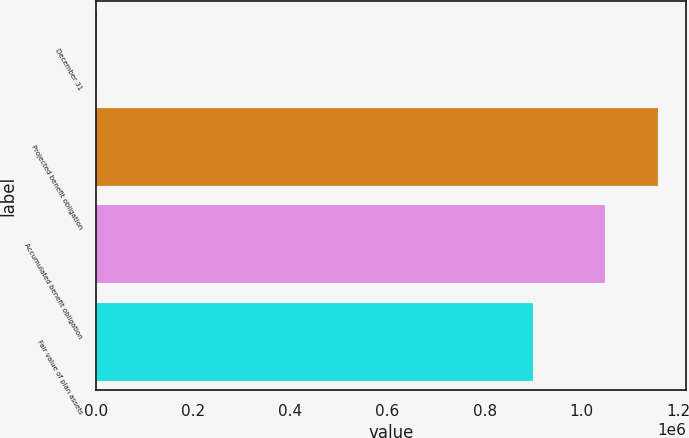Convert chart to OTSL. <chart><loc_0><loc_0><loc_500><loc_500><bar_chart><fcel>December 31<fcel>Projected benefit obligation<fcel>Accumulated benefit obligation<fcel>Fair value of plan assets<nl><fcel>2011<fcel>1.15753e+06<fcel>1.049e+06<fcel>898852<nl></chart> 